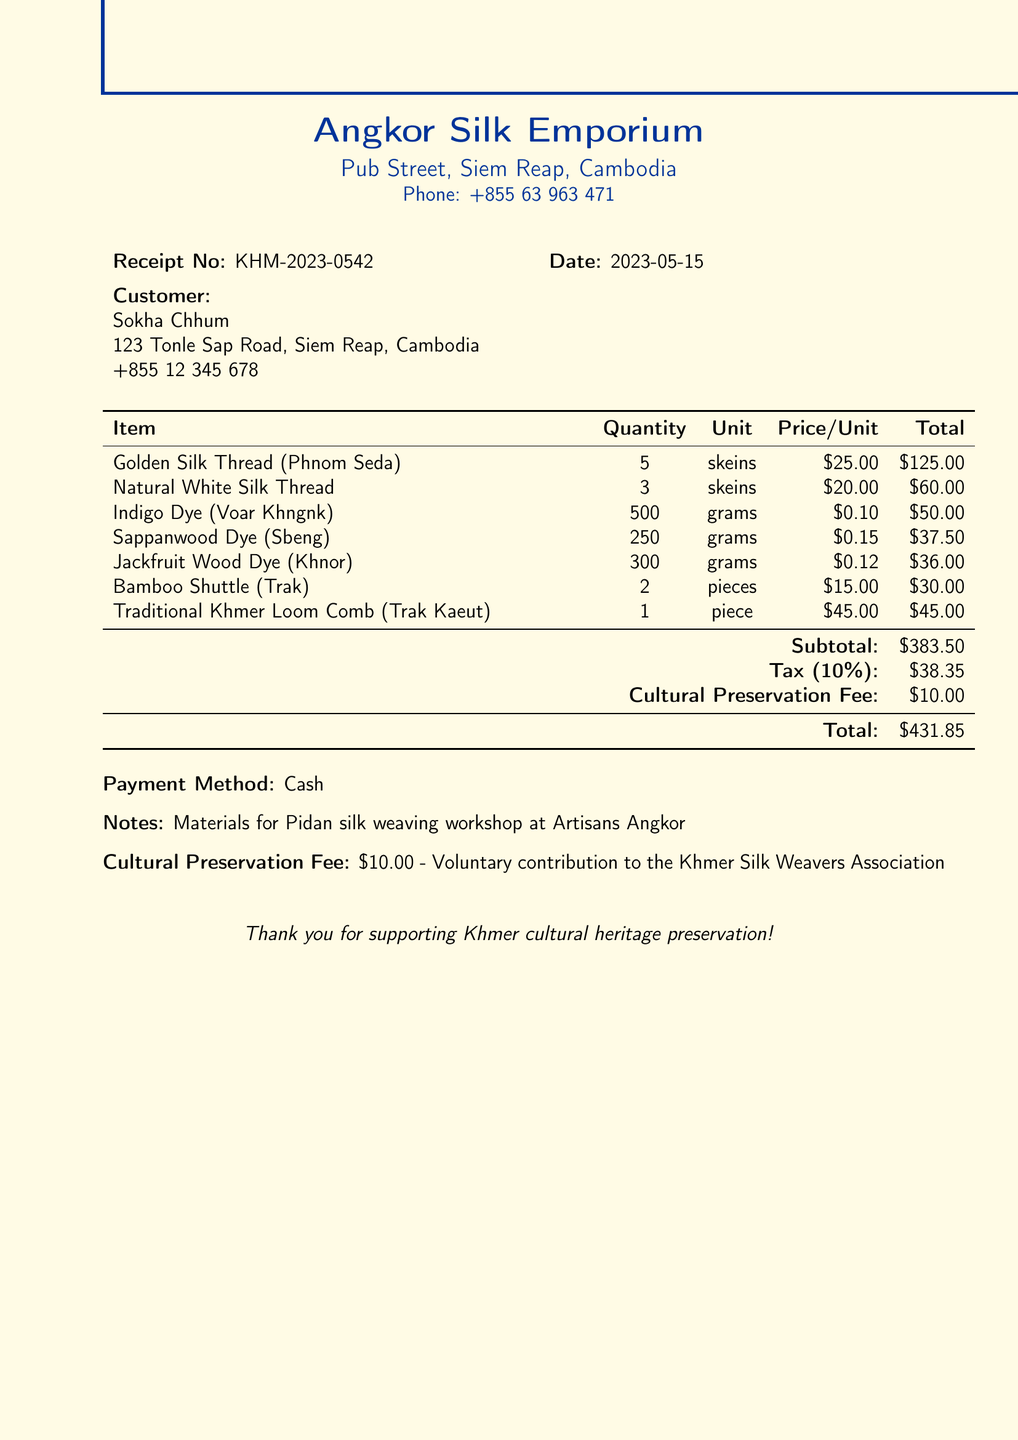what is the receipt number? The receipt number is listed at the top of the document as KHM-2023-0542.
Answer: KHM-2023-0542 who is the vendor? The vendor information includes the name, which is Angkor Silk Emporium.
Answer: Angkor Silk Emporium what is the total cost? The total cost is located at the bottom of the document, which sums up all items, tax, and fees.
Answer: 421.85 how many skeins of Golden Silk Thread were purchased? The quantity of the Golden Silk Thread is specified as 5 skeins in the itemized list.
Answer: 5 what is the cultural preservation fee amount? The cultural preservation fee is indicated as a voluntary contribution amount, which is $10.00.
Answer: 10.00 what date was the purchase made? The date of the transaction is mentioned in the initial section of the document as 2023-05-15.
Answer: 2023-05-15 how many pieces of the Traditional Khmer Loom Comb were bought? The document specifies that 1 piece of the Traditional Khmer Loom Comb was purchased.
Answer: 1 what is the tax percentage applied? The tax is mentioned with a description of 10%, which is calculated on the subtotal.
Answer: 10% what method of payment was used? The payment method is stated in the document as Cash.
Answer: Cash 